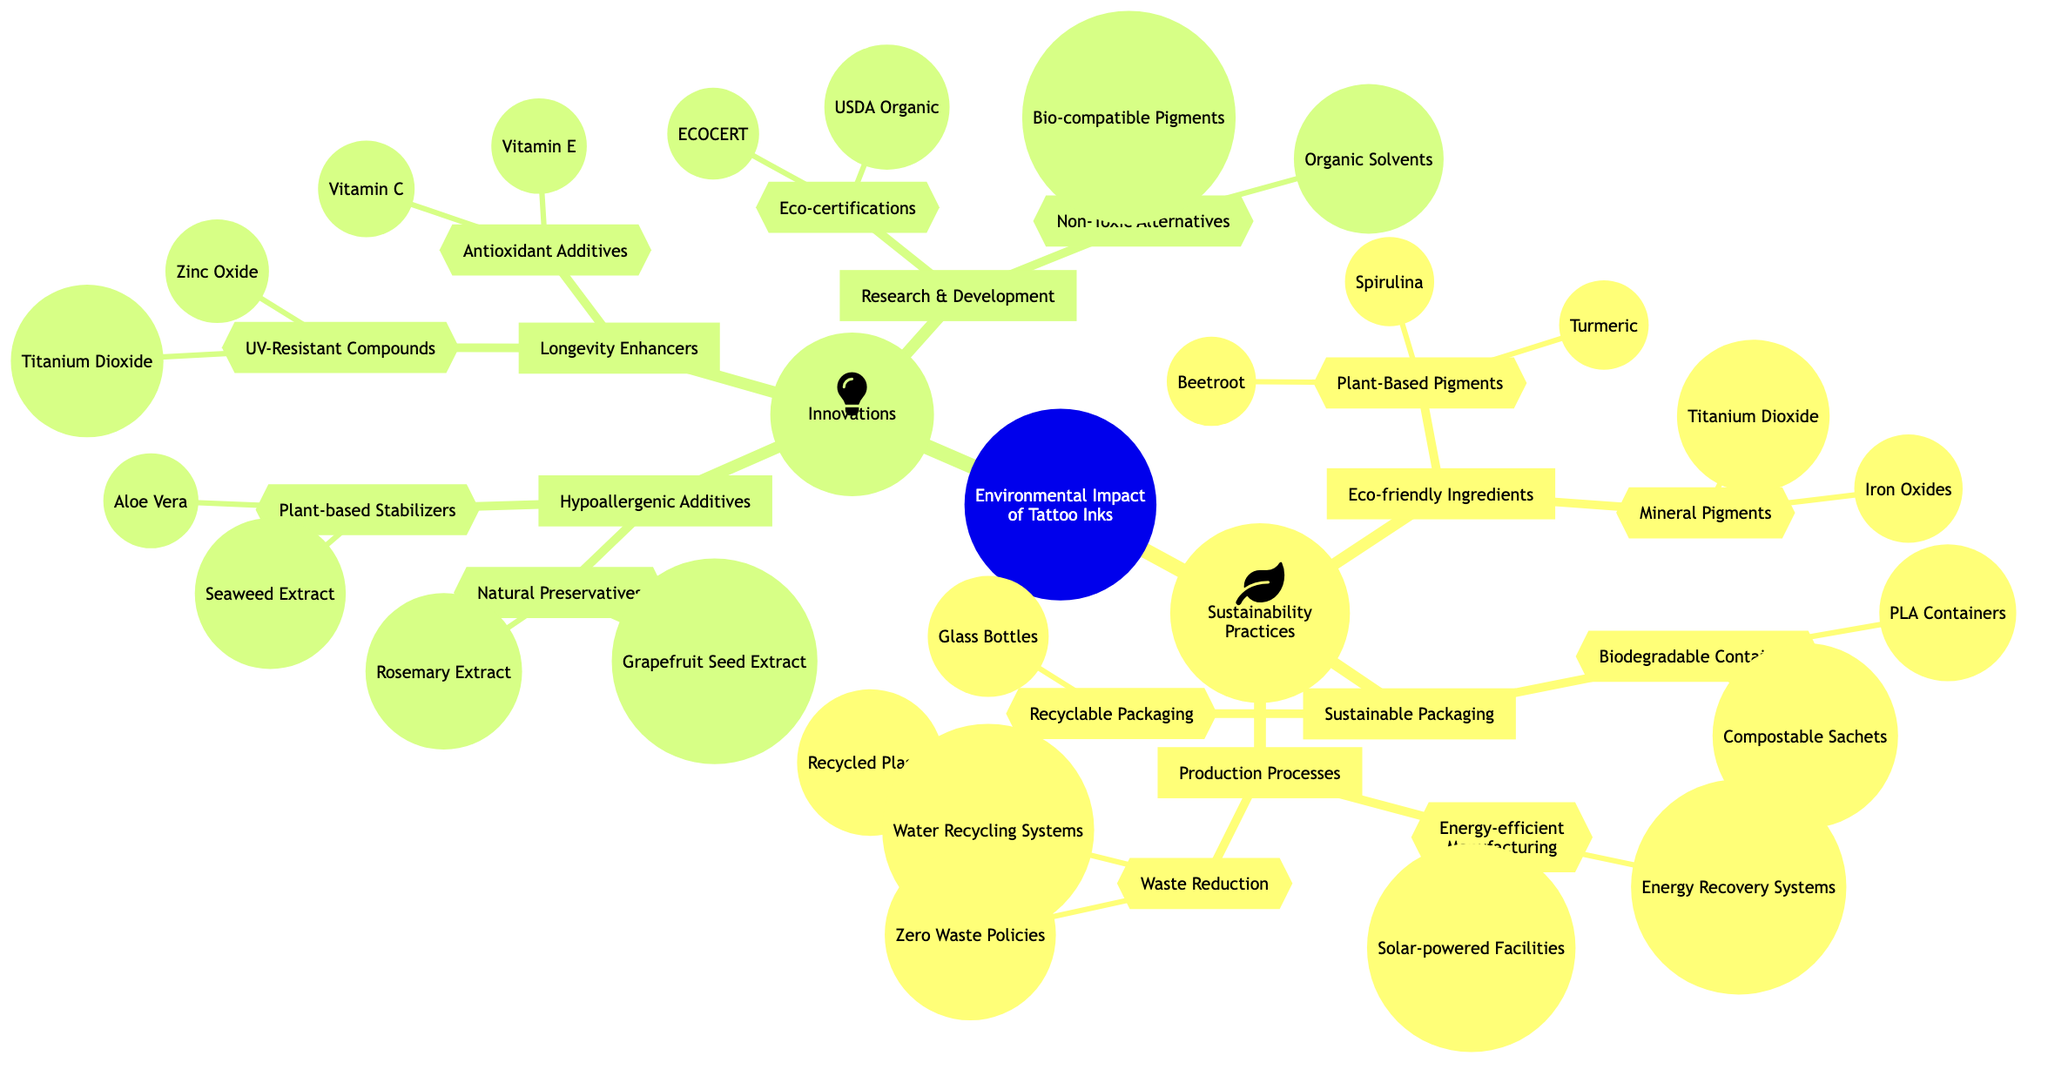What's an example of a plant-based pigment used in tattoo inks? The diagram lists several plant-based pigments under the Eco-friendly Ingredients section, one of which is Turmeric.
Answer: Turmeric How many types of sustainable packaging are mentioned in the diagram? The Sustainable Packaging section has two types: Biodegradable Containers and Recyclable Packaging, thus together they indicate a total of 2 types.
Answer: 2 Which compound is listed as a UV-Resistant compound? In the Longevity Enhancers section, Zinc Oxide is one of the compounds categorized as UV-Resistant.
Answer: Zinc Oxide What type of manufacturing system is included under Energy-efficient Manufacturing? The diagram specifies Solar-powered Facilities as an energy-efficient option within the Production Processes section.
Answer: Solar-powered Facilities What is the primary focus of the Innovations section in the diagram? The Innovations section aims to highlight improvements in tattoo inks, showcasing Hypoallergenic Additives, Longevity Enhancers, and Research & Development. This indicates that the primary focus is the advancement of ink formulations.
Answer: Advancement of ink formulations Name a type of natural preservative listed under Hypoallergenic Additives. The diagram notes Grapefruit Seed Extract as a natural preservative within the Hypoallergenic Additives category.
Answer: Grapefruit Seed Extract How are Biodegradable Containers categorized in the diagram? Biodegradable Containers fall under the Sustainable Packaging node, illustrating an environmentally friendly option for packaging tattoo inks.
Answer: Sustainable Packaging What is one benefit of using mineral pigments in tattoo inks according to the concept map? Mineral Pigments such as Iron Oxides and Titanium Dioxide are included in the Eco-friendly Ingredients, suggesting they provide vibrant and stable colors, therefore benefiting the longevity and safety of the inks.
Answer: Vibrant and stable colors How many natural preservatives are listed in the diagram? The Hypoallergenic Additives section provides two examples of natural preservatives: Grapefruit Seed Extract and Rosemary Extract, leading to a total of 2.
Answer: 2 